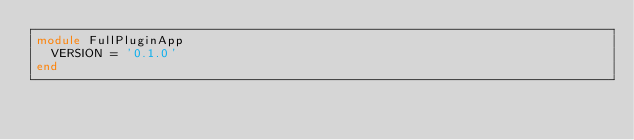Convert code to text. <code><loc_0><loc_0><loc_500><loc_500><_Ruby_>module FullPluginApp
  VERSION = '0.1.0'
end
</code> 